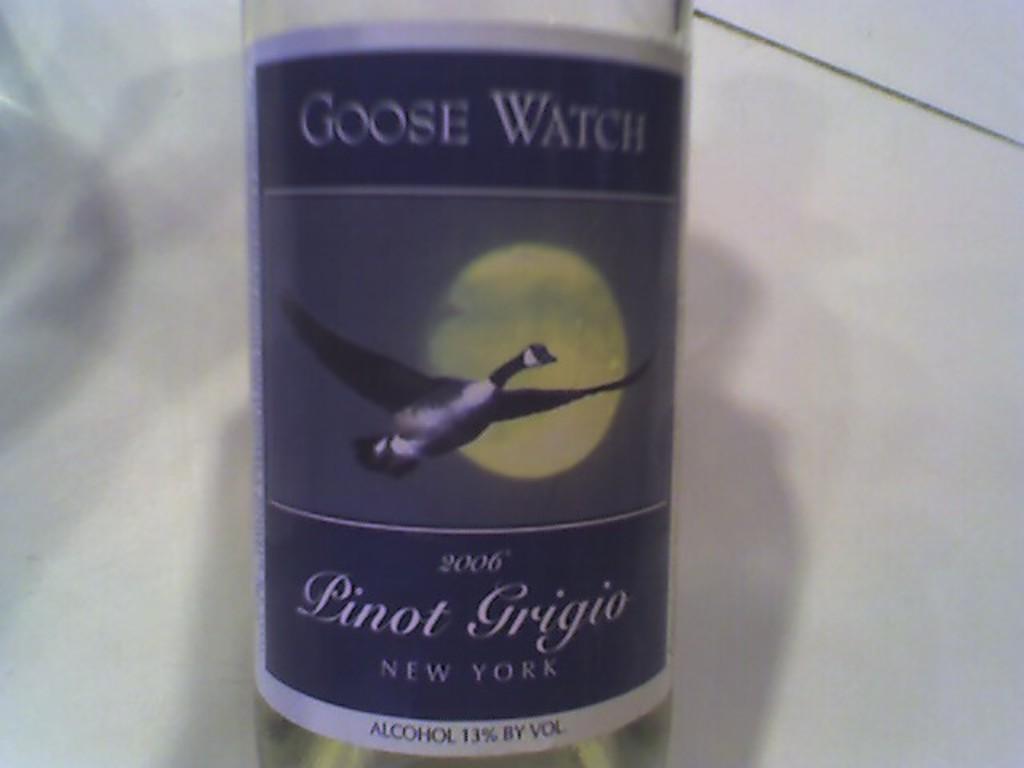What is the year of the pinot grigio?
Make the answer very short. 2006. What kind of watch on it?
Your response must be concise. Goose. 